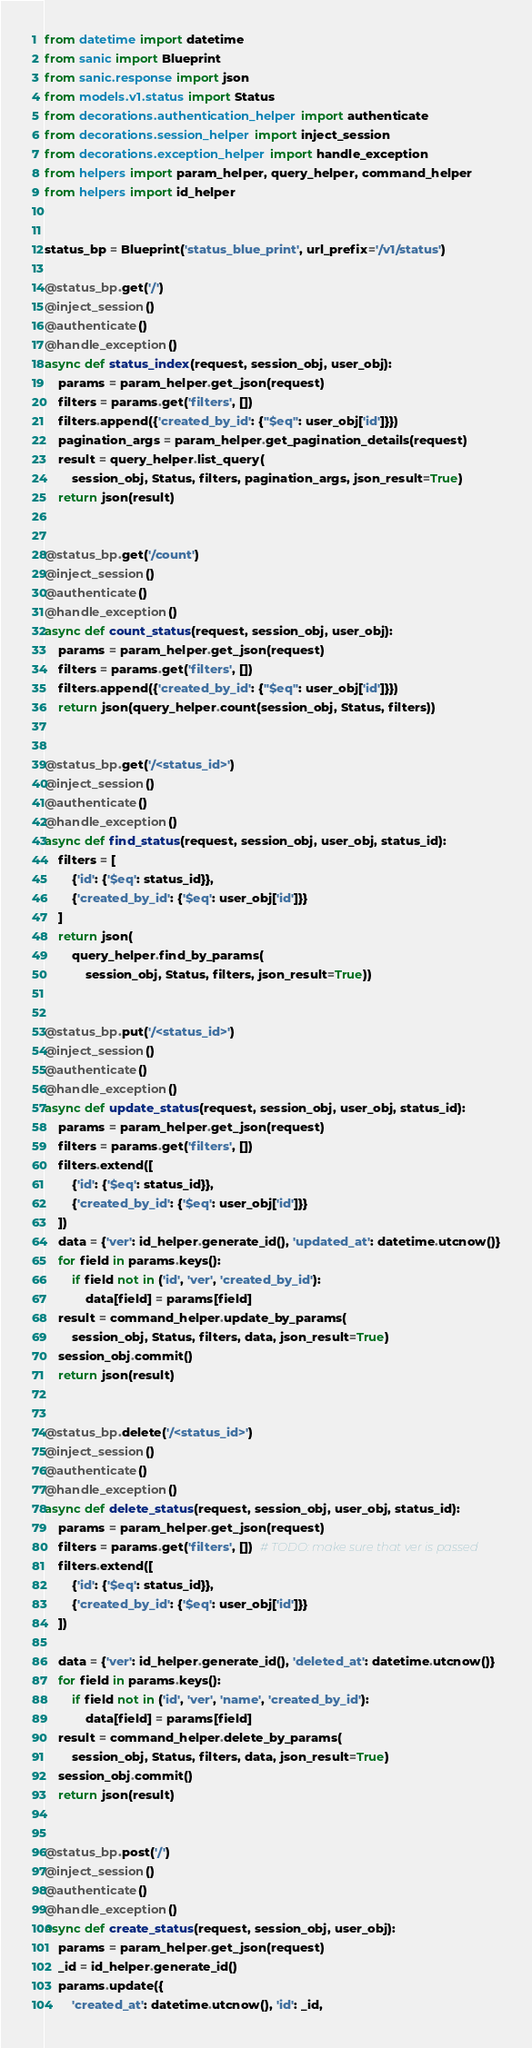Convert code to text. <code><loc_0><loc_0><loc_500><loc_500><_Python_>from datetime import datetime
from sanic import Blueprint
from sanic.response import json
from models.v1.status import Status
from decorations.authentication_helper import authenticate
from decorations.session_helper import inject_session
from decorations.exception_helper import handle_exception
from helpers import param_helper, query_helper, command_helper
from helpers import id_helper


status_bp = Blueprint('status_blue_print', url_prefix='/v1/status')

@status_bp.get('/')
@inject_session()
@authenticate()
@handle_exception()
async def status_index(request, session_obj, user_obj):
    params = param_helper.get_json(request)
    filters = params.get('filters', [])
    filters.append({'created_by_id': {"$eq": user_obj['id']}})
    pagination_args = param_helper.get_pagination_details(request)
    result = query_helper.list_query(
        session_obj, Status, filters, pagination_args, json_result=True)
    return json(result)


@status_bp.get('/count')
@inject_session()
@authenticate()
@handle_exception()
async def count_status(request, session_obj, user_obj):
    params = param_helper.get_json(request)
    filters = params.get('filters', [])
    filters.append({'created_by_id': {"$eq": user_obj['id']}})
    return json(query_helper.count(session_obj, Status, filters))


@status_bp.get('/<status_id>')
@inject_session()
@authenticate()
@handle_exception()
async def find_status(request, session_obj, user_obj, status_id):
    filters = [
        {'id': {'$eq': status_id}},
        {'created_by_id': {'$eq': user_obj['id']}}
    ]
    return json(
        query_helper.find_by_params(
            session_obj, Status, filters, json_result=True))


@status_bp.put('/<status_id>')
@inject_session()
@authenticate()
@handle_exception()
async def update_status(request, session_obj, user_obj, status_id):
    params = param_helper.get_json(request)
    filters = params.get('filters', [])
    filters.extend([
        {'id': {'$eq': status_id}},
        {'created_by_id': {'$eq': user_obj['id']}}
    ])
    data = {'ver': id_helper.generate_id(), 'updated_at': datetime.utcnow()}
    for field in params.keys():
        if field not in ('id', 'ver', 'created_by_id'):
            data[field] = params[field]
    result = command_helper.update_by_params(
        session_obj, Status, filters, data, json_result=True)
    session_obj.commit()
    return json(result)


@status_bp.delete('/<status_id>')
@inject_session()
@authenticate()
@handle_exception()
async def delete_status(request, session_obj, user_obj, status_id):
    params = param_helper.get_json(request)
    filters = params.get('filters', [])  # TODO: make sure that ver is passed
    filters.extend([
        {'id': {'$eq': status_id}},
        {'created_by_id': {'$eq': user_obj['id']}}
    ])

    data = {'ver': id_helper.generate_id(), 'deleted_at': datetime.utcnow()}
    for field in params.keys():
        if field not in ('id', 'ver', 'name', 'created_by_id'):
            data[field] = params[field]
    result = command_helper.delete_by_params(
        session_obj, Status, filters, data, json_result=True)
    session_obj.commit()
    return json(result)


@status_bp.post('/')
@inject_session()
@authenticate()
@handle_exception()
async def create_status(request, session_obj, user_obj):
    params = param_helper.get_json(request)
    _id = id_helper.generate_id()
    params.update({
        'created_at': datetime.utcnow(), 'id': _id,</code> 